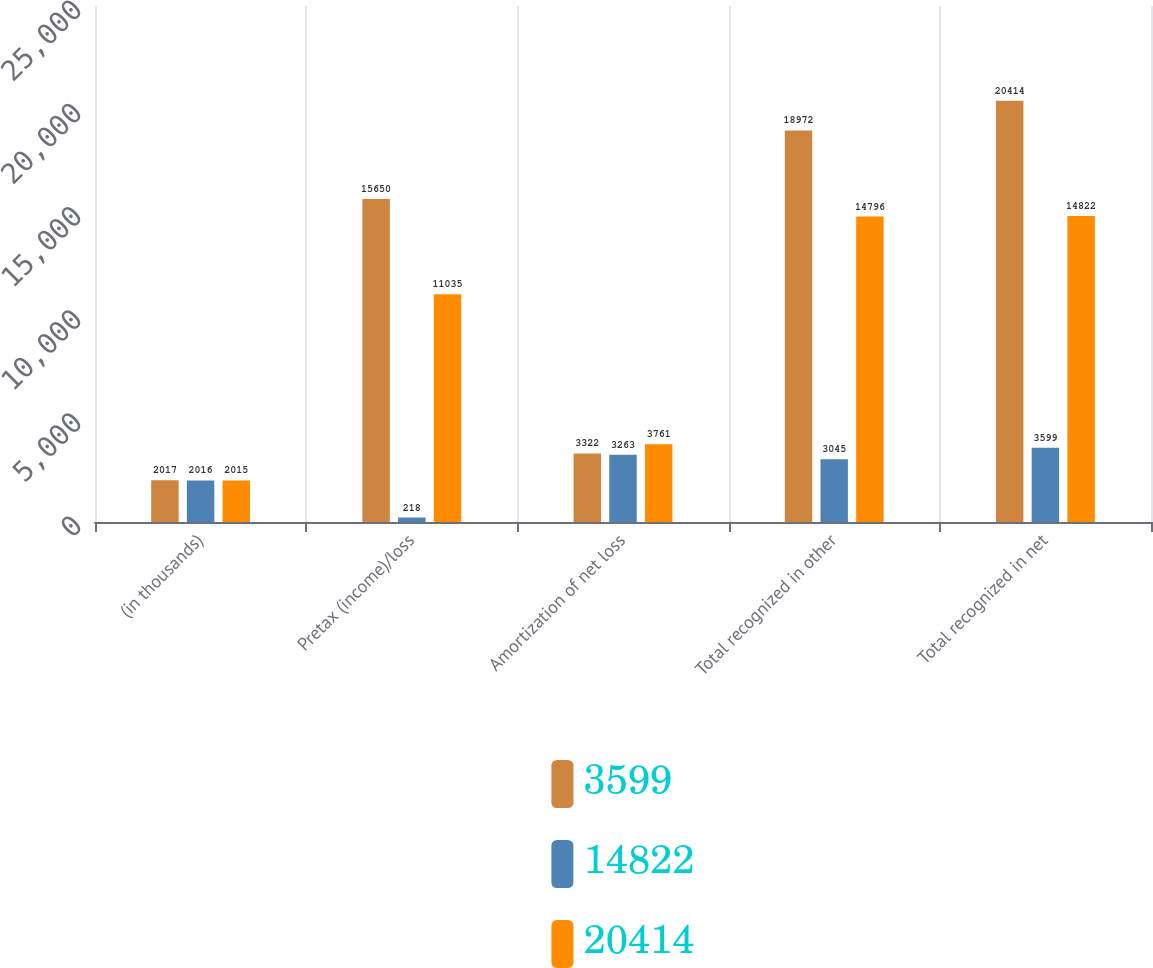Convert chart. <chart><loc_0><loc_0><loc_500><loc_500><stacked_bar_chart><ecel><fcel>(in thousands)<fcel>Pretax (income)/loss<fcel>Amortization of net loss<fcel>Total recognized in other<fcel>Total recognized in net<nl><fcel>3599<fcel>2017<fcel>15650<fcel>3322<fcel>18972<fcel>20414<nl><fcel>14822<fcel>2016<fcel>218<fcel>3263<fcel>3045<fcel>3599<nl><fcel>20414<fcel>2015<fcel>11035<fcel>3761<fcel>14796<fcel>14822<nl></chart> 